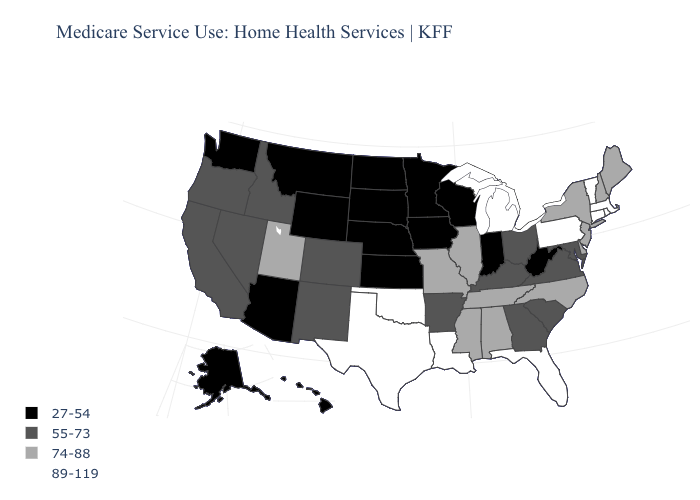Which states hav the highest value in the MidWest?
Be succinct. Michigan. What is the value of Kansas?
Give a very brief answer. 27-54. Does Kentucky have the same value as Connecticut?
Quick response, please. No. Name the states that have a value in the range 74-88?
Short answer required. Alabama, Delaware, Illinois, Maine, Mississippi, Missouri, New Hampshire, New Jersey, New York, North Carolina, Tennessee, Utah. Among the states that border New Jersey , does Pennsylvania have the highest value?
Concise answer only. Yes. What is the value of New Jersey?
Short answer required. 74-88. Name the states that have a value in the range 89-119?
Write a very short answer. Connecticut, Florida, Louisiana, Massachusetts, Michigan, Oklahoma, Pennsylvania, Rhode Island, Texas, Vermont. Does Kansas have the lowest value in the USA?
Short answer required. Yes. What is the lowest value in the MidWest?
Concise answer only. 27-54. Which states have the lowest value in the USA?
Quick response, please. Alaska, Arizona, Hawaii, Indiana, Iowa, Kansas, Minnesota, Montana, Nebraska, North Dakota, South Dakota, Washington, West Virginia, Wisconsin, Wyoming. Name the states that have a value in the range 27-54?
Answer briefly. Alaska, Arizona, Hawaii, Indiana, Iowa, Kansas, Minnesota, Montana, Nebraska, North Dakota, South Dakota, Washington, West Virginia, Wisconsin, Wyoming. Which states have the lowest value in the USA?
Concise answer only. Alaska, Arizona, Hawaii, Indiana, Iowa, Kansas, Minnesota, Montana, Nebraska, North Dakota, South Dakota, Washington, West Virginia, Wisconsin, Wyoming. Name the states that have a value in the range 89-119?
Short answer required. Connecticut, Florida, Louisiana, Massachusetts, Michigan, Oklahoma, Pennsylvania, Rhode Island, Texas, Vermont. Does the first symbol in the legend represent the smallest category?
Be succinct. Yes. Name the states that have a value in the range 27-54?
Short answer required. Alaska, Arizona, Hawaii, Indiana, Iowa, Kansas, Minnesota, Montana, Nebraska, North Dakota, South Dakota, Washington, West Virginia, Wisconsin, Wyoming. 